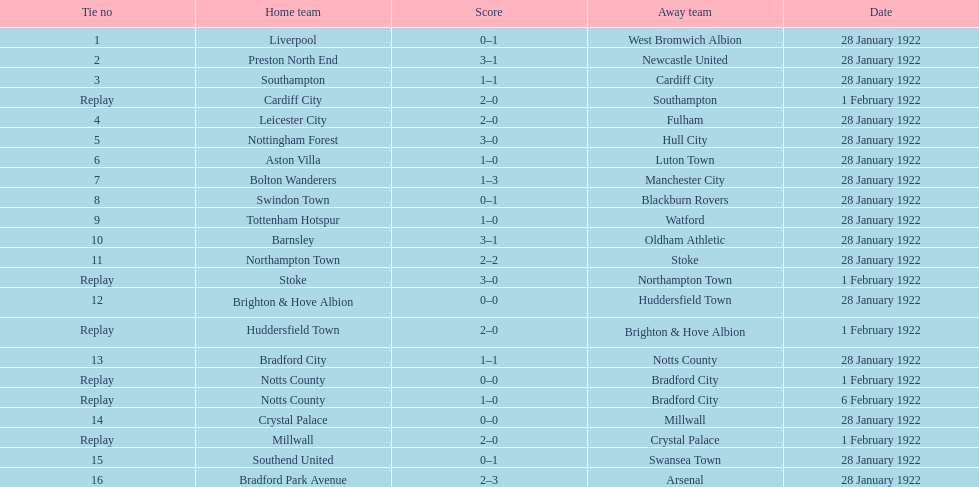On january 28th, 1922, which home team shared the same score as aston villa? Tottenham Hotspur. 